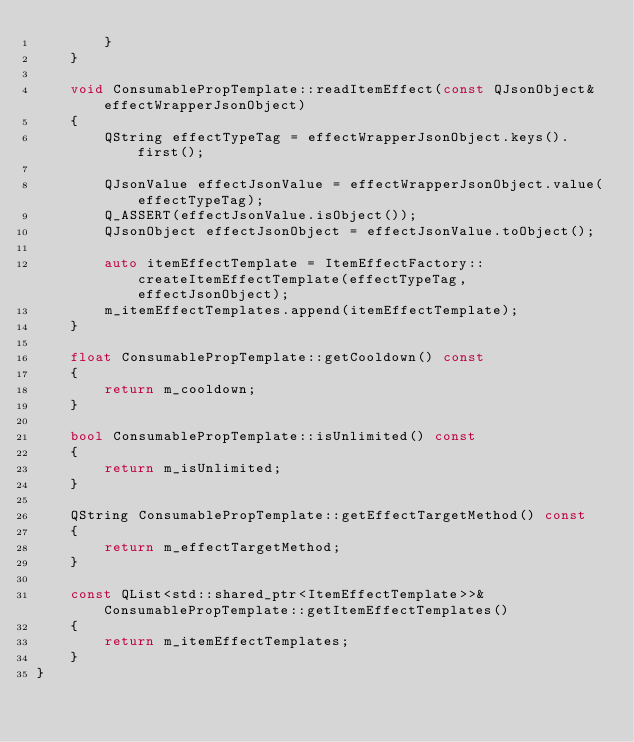<code> <loc_0><loc_0><loc_500><loc_500><_C++_>        }
    }

    void ConsumablePropTemplate::readItemEffect(const QJsonObject& effectWrapperJsonObject)
    {
        QString effectTypeTag = effectWrapperJsonObject.keys().first();

        QJsonValue effectJsonValue = effectWrapperJsonObject.value(effectTypeTag);
        Q_ASSERT(effectJsonValue.isObject());
        QJsonObject effectJsonObject = effectJsonValue.toObject();

        auto itemEffectTemplate = ItemEffectFactory::createItemEffectTemplate(effectTypeTag, effectJsonObject);
        m_itemEffectTemplates.append(itemEffectTemplate);
    }

    float ConsumablePropTemplate::getCooldown() const
    {
        return m_cooldown;
    }

    bool ConsumablePropTemplate::isUnlimited() const
    {
        return m_isUnlimited;
    }

    QString ConsumablePropTemplate::getEffectTargetMethod() const
    {
        return m_effectTargetMethod;
    }

    const QList<std::shared_ptr<ItemEffectTemplate>>& ConsumablePropTemplate::getItemEffectTemplates()
    {
        return m_itemEffectTemplates;
    }
}
</code> 